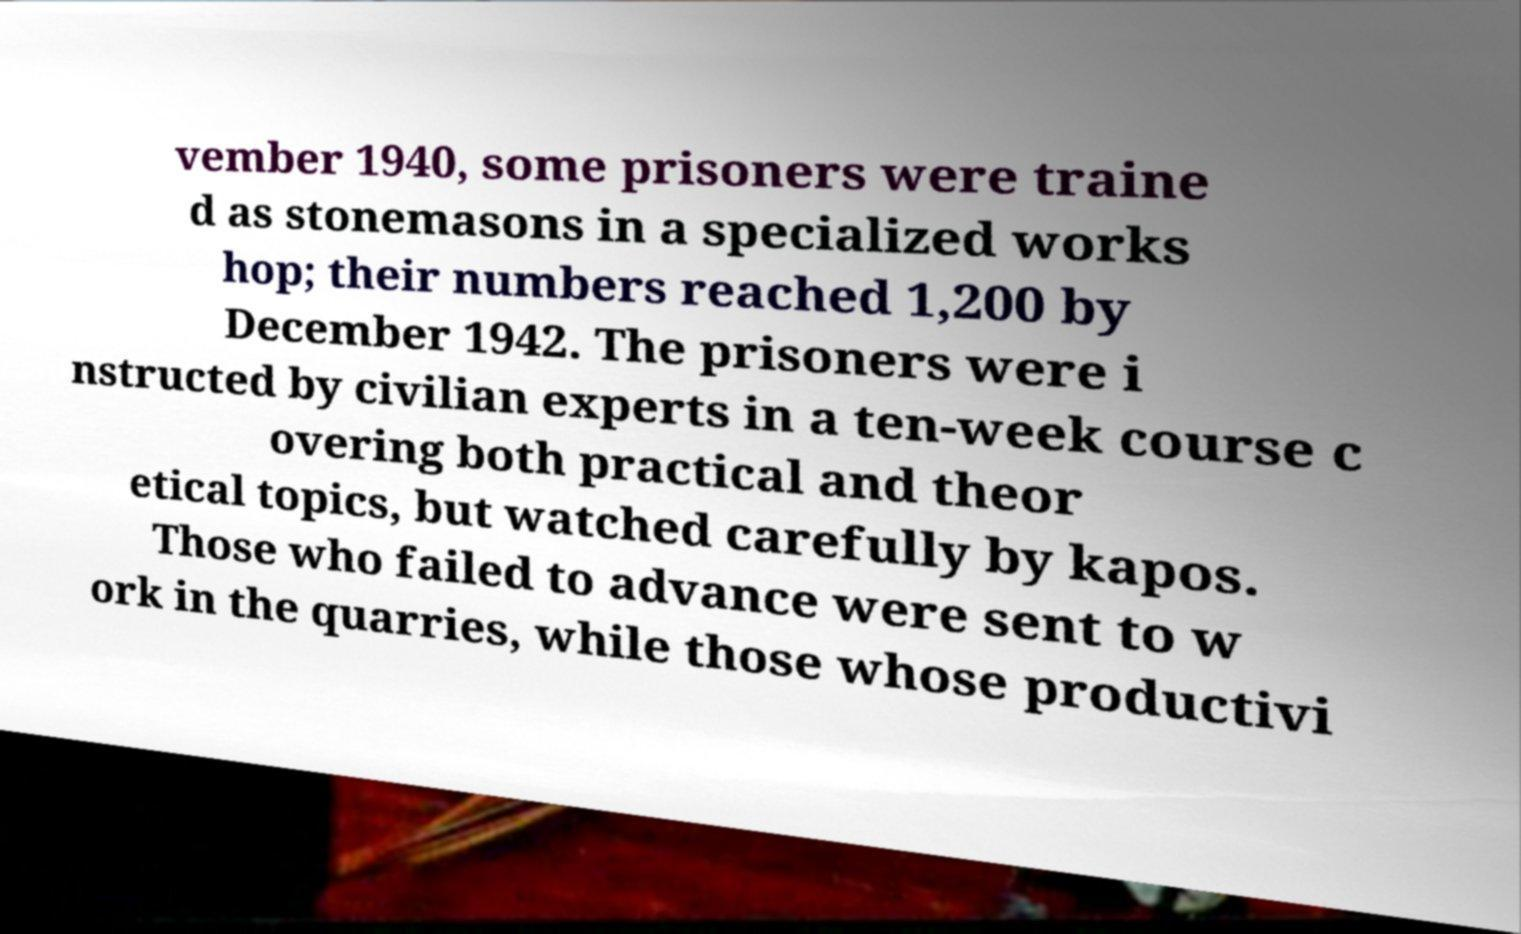For documentation purposes, I need the text within this image transcribed. Could you provide that? vember 1940, some prisoners were traine d as stonemasons in a specialized works hop; their numbers reached 1,200 by December 1942. The prisoners were i nstructed by civilian experts in a ten-week course c overing both practical and theor etical topics, but watched carefully by kapos. Those who failed to advance were sent to w ork in the quarries, while those whose productivi 